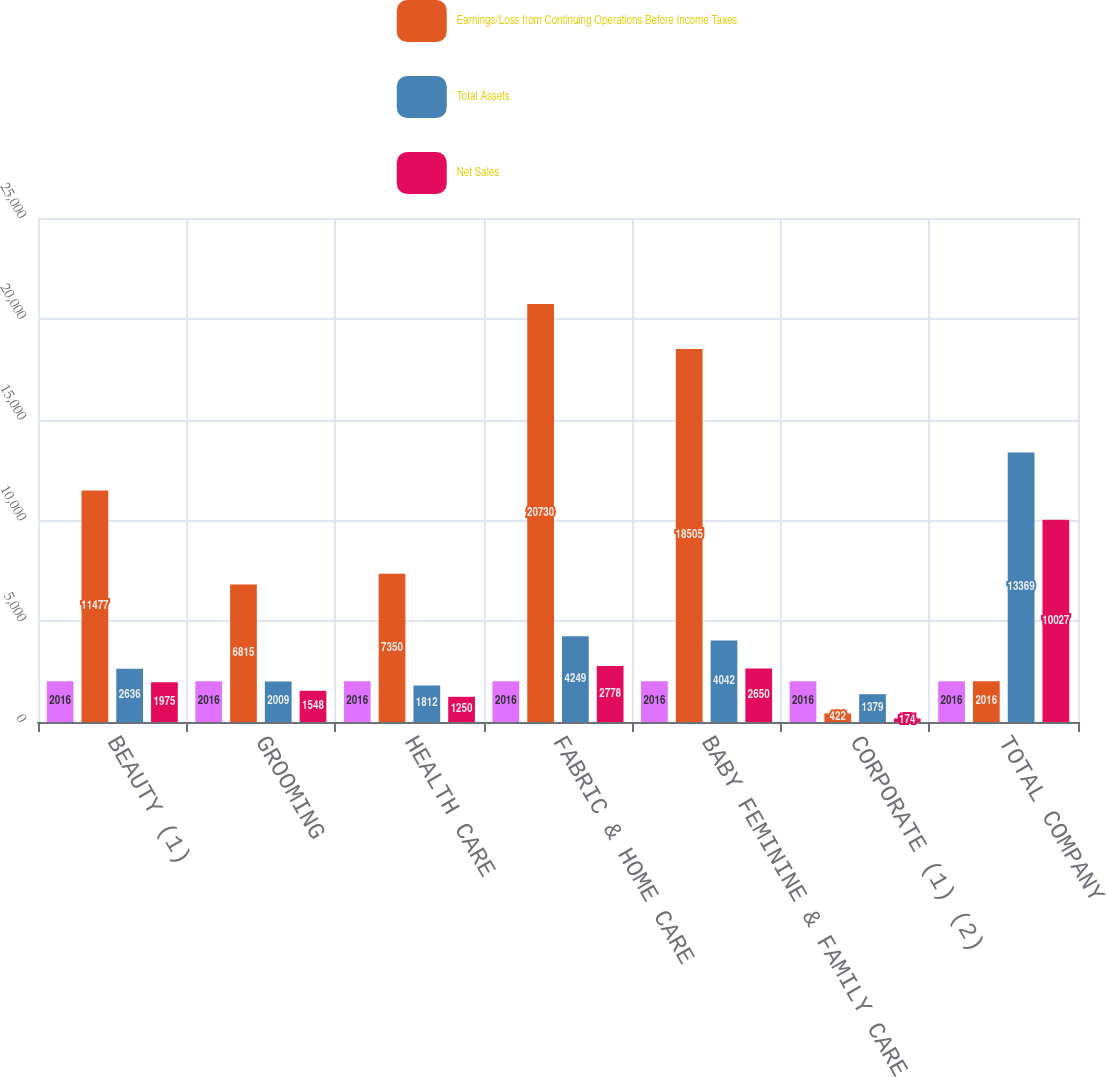Convert chart to OTSL. <chart><loc_0><loc_0><loc_500><loc_500><stacked_bar_chart><ecel><fcel>BEAUTY (1)<fcel>GROOMING<fcel>HEALTH CARE<fcel>FABRIC & HOME CARE<fcel>BABY FEMININE & FAMILY CARE<fcel>CORPORATE (1) (2)<fcel>TOTAL COMPANY<nl><fcel>nan<fcel>2016<fcel>2016<fcel>2016<fcel>2016<fcel>2016<fcel>2016<fcel>2016<nl><fcel>Earnings/Loss from Continuing Operations Before Income Taxes<fcel>11477<fcel>6815<fcel>7350<fcel>20730<fcel>18505<fcel>422<fcel>2016<nl><fcel>Total Assets<fcel>2636<fcel>2009<fcel>1812<fcel>4249<fcel>4042<fcel>1379<fcel>13369<nl><fcel>Net Sales<fcel>1975<fcel>1548<fcel>1250<fcel>2778<fcel>2650<fcel>174<fcel>10027<nl></chart> 